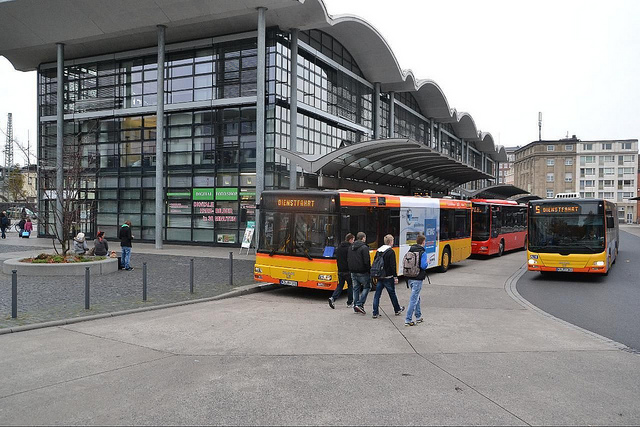How many buses are there? There are three buses visible in the image, each displaying different route information and painted in unique color schemes indicative of their respective routes or services. 